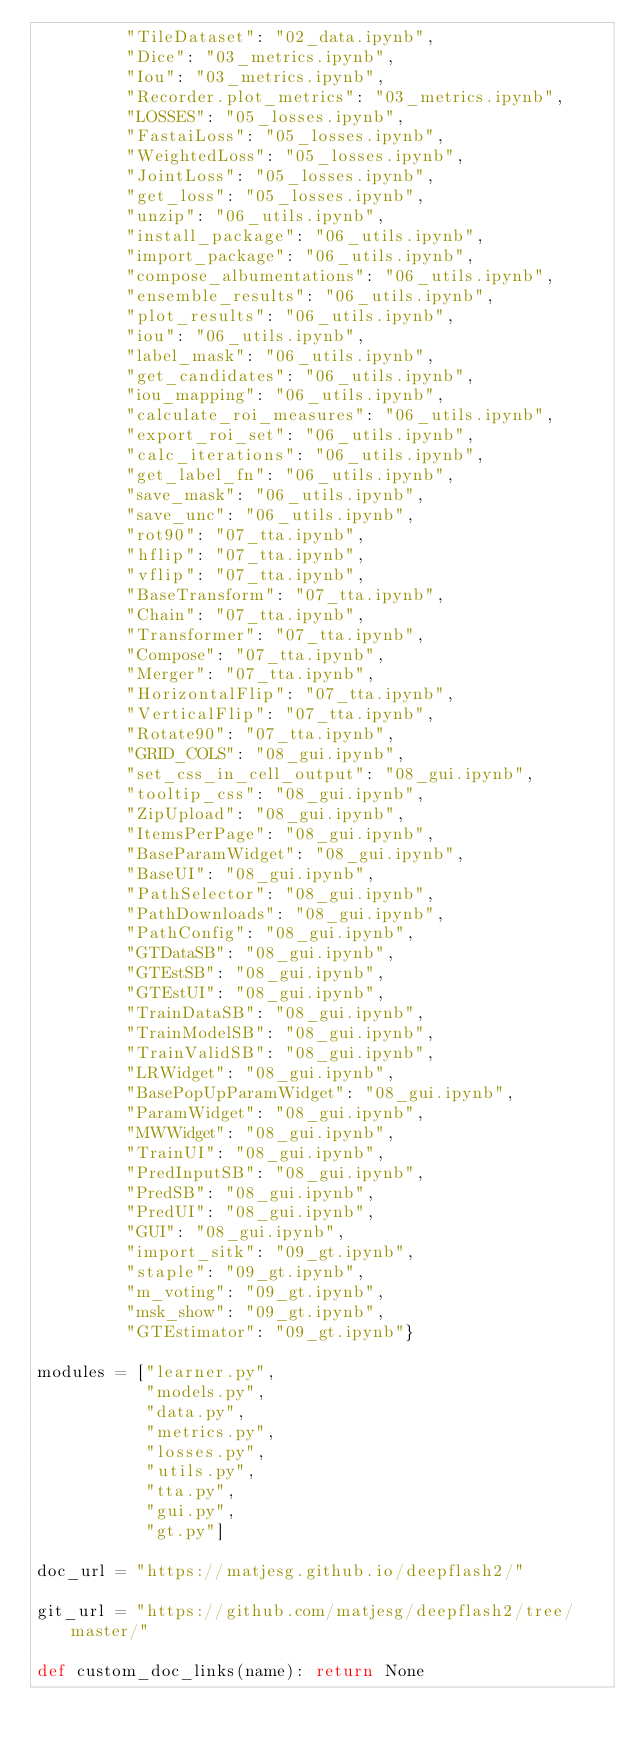Convert code to text. <code><loc_0><loc_0><loc_500><loc_500><_Python_>         "TileDataset": "02_data.ipynb",
         "Dice": "03_metrics.ipynb",
         "Iou": "03_metrics.ipynb",
         "Recorder.plot_metrics": "03_metrics.ipynb",
         "LOSSES": "05_losses.ipynb",
         "FastaiLoss": "05_losses.ipynb",
         "WeightedLoss": "05_losses.ipynb",
         "JointLoss": "05_losses.ipynb",
         "get_loss": "05_losses.ipynb",
         "unzip": "06_utils.ipynb",
         "install_package": "06_utils.ipynb",
         "import_package": "06_utils.ipynb",
         "compose_albumentations": "06_utils.ipynb",
         "ensemble_results": "06_utils.ipynb",
         "plot_results": "06_utils.ipynb",
         "iou": "06_utils.ipynb",
         "label_mask": "06_utils.ipynb",
         "get_candidates": "06_utils.ipynb",
         "iou_mapping": "06_utils.ipynb",
         "calculate_roi_measures": "06_utils.ipynb",
         "export_roi_set": "06_utils.ipynb",
         "calc_iterations": "06_utils.ipynb",
         "get_label_fn": "06_utils.ipynb",
         "save_mask": "06_utils.ipynb",
         "save_unc": "06_utils.ipynb",
         "rot90": "07_tta.ipynb",
         "hflip": "07_tta.ipynb",
         "vflip": "07_tta.ipynb",
         "BaseTransform": "07_tta.ipynb",
         "Chain": "07_tta.ipynb",
         "Transformer": "07_tta.ipynb",
         "Compose": "07_tta.ipynb",
         "Merger": "07_tta.ipynb",
         "HorizontalFlip": "07_tta.ipynb",
         "VerticalFlip": "07_tta.ipynb",
         "Rotate90": "07_tta.ipynb",
         "GRID_COLS": "08_gui.ipynb",
         "set_css_in_cell_output": "08_gui.ipynb",
         "tooltip_css": "08_gui.ipynb",
         "ZipUpload": "08_gui.ipynb",
         "ItemsPerPage": "08_gui.ipynb",
         "BaseParamWidget": "08_gui.ipynb",
         "BaseUI": "08_gui.ipynb",
         "PathSelector": "08_gui.ipynb",
         "PathDownloads": "08_gui.ipynb",
         "PathConfig": "08_gui.ipynb",
         "GTDataSB": "08_gui.ipynb",
         "GTEstSB": "08_gui.ipynb",
         "GTEstUI": "08_gui.ipynb",
         "TrainDataSB": "08_gui.ipynb",
         "TrainModelSB": "08_gui.ipynb",
         "TrainValidSB": "08_gui.ipynb",
         "LRWidget": "08_gui.ipynb",
         "BasePopUpParamWidget": "08_gui.ipynb",
         "ParamWidget": "08_gui.ipynb",
         "MWWidget": "08_gui.ipynb",
         "TrainUI": "08_gui.ipynb",
         "PredInputSB": "08_gui.ipynb",
         "PredSB": "08_gui.ipynb",
         "PredUI": "08_gui.ipynb",
         "GUI": "08_gui.ipynb",
         "import_sitk": "09_gt.ipynb",
         "staple": "09_gt.ipynb",
         "m_voting": "09_gt.ipynb",
         "msk_show": "09_gt.ipynb",
         "GTEstimator": "09_gt.ipynb"}

modules = ["learner.py",
           "models.py",
           "data.py",
           "metrics.py",
           "losses.py",
           "utils.py",
           "tta.py",
           "gui.py",
           "gt.py"]

doc_url = "https://matjesg.github.io/deepflash2/"

git_url = "https://github.com/matjesg/deepflash2/tree/master/"

def custom_doc_links(name): return None
</code> 